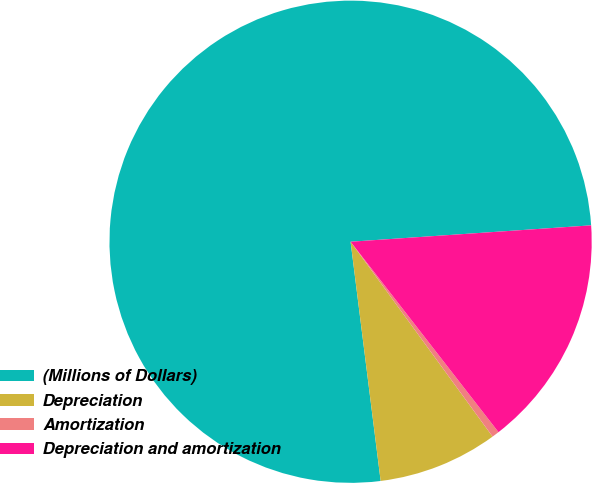Convert chart to OTSL. <chart><loc_0><loc_0><loc_500><loc_500><pie_chart><fcel>(Millions of Dollars)<fcel>Depreciation<fcel>Amortization<fcel>Depreciation and amortization<nl><fcel>75.9%<fcel>8.03%<fcel>0.49%<fcel>15.57%<nl></chart> 